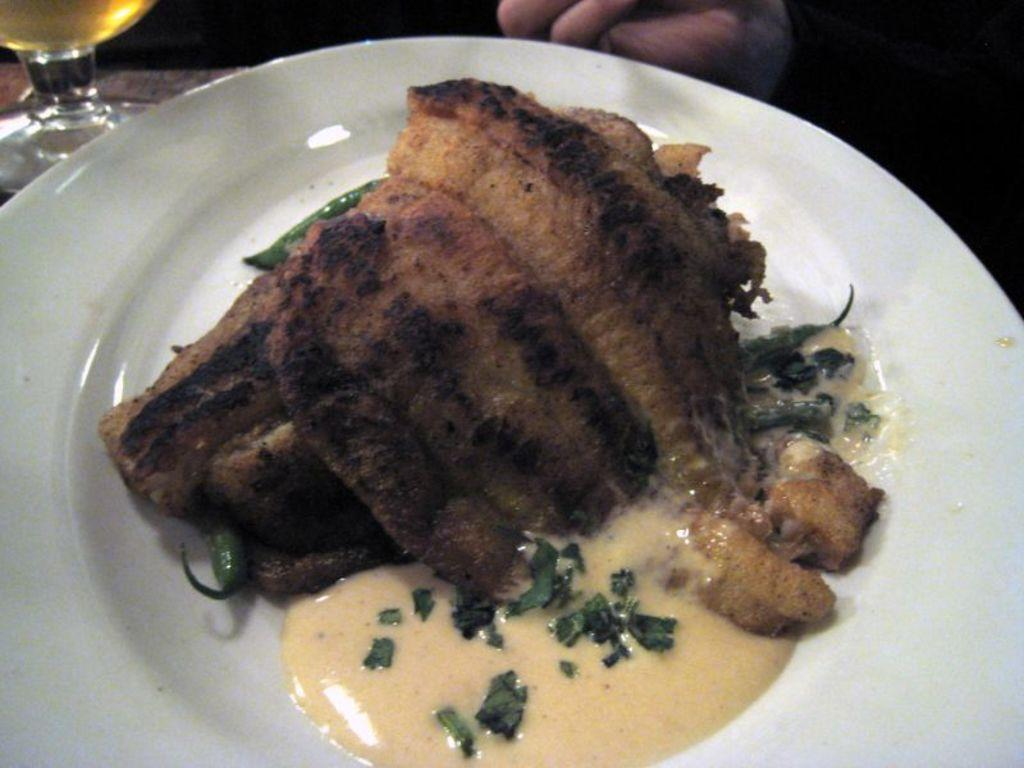What is on the plate in the image in the image? There is a food item on a plate in the image. Where is the plate located? The plate is on a table. What is beside the plate on the table? There is a glass beside the plate. What else is beside the plate and glass on the table? There is an unspecified object beside the plate and glass. Is there any smoke coming from the food item on the plate in the image? No, there is no smoke present in the image. 